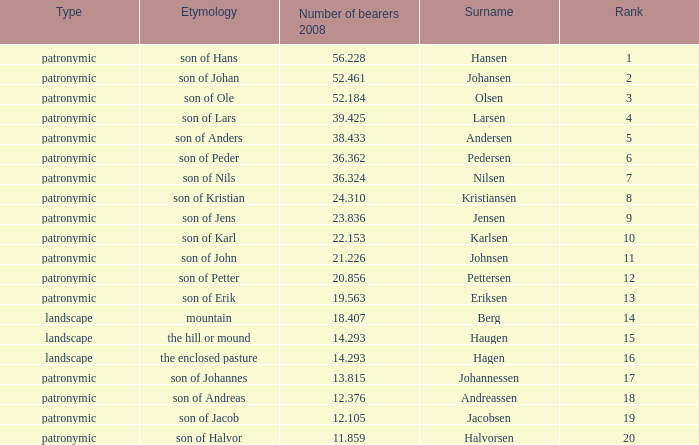What is the highest Number of Bearers 2008, when Surname is Hansen, and when Rank is less than 1? None. 